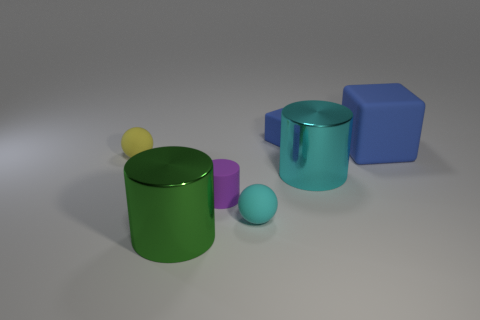Subtract 1 cylinders. How many cylinders are left? 2 Add 2 rubber cylinders. How many objects exist? 9 Subtract all tiny cyan balls. Subtract all metallic cylinders. How many objects are left? 4 Add 6 blue matte blocks. How many blue matte blocks are left? 8 Add 4 purple shiny spheres. How many purple shiny spheres exist? 4 Subtract 0 red spheres. How many objects are left? 7 Subtract all blocks. How many objects are left? 5 